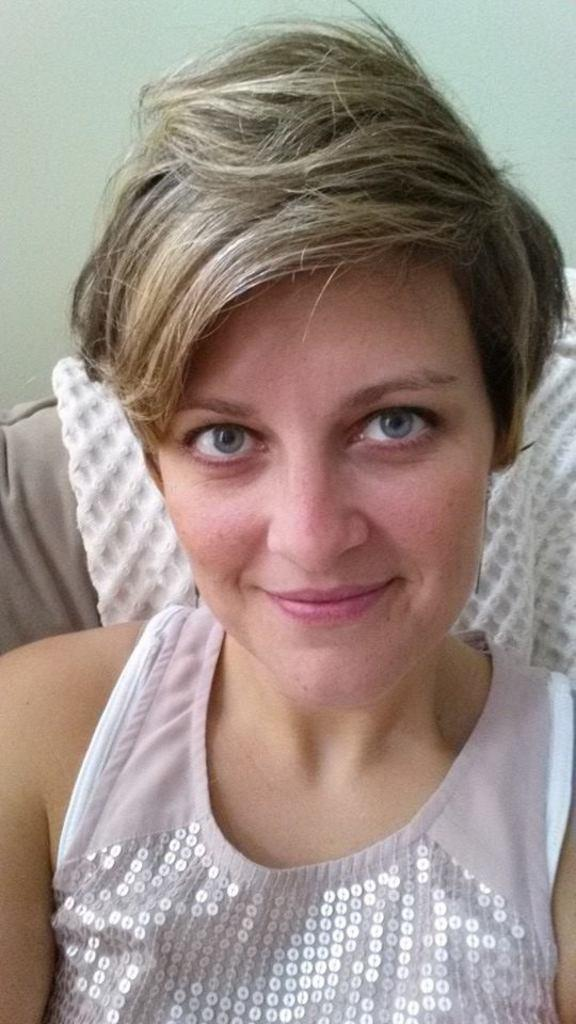Who is the main subject in the image? There is a woman in the center of the image. What can be seen in the background of the image? There is a couch and a wall visible in the background of the image. What is on the couch? There is cloth on the couch. What historical event is the woman discussing with the actor in the image? There is no actor present in the image, and the woman is not discussing any historical events. 